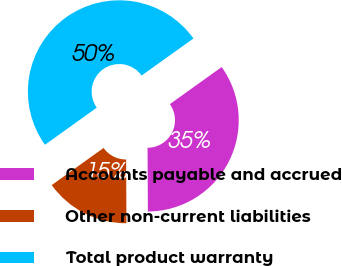<chart> <loc_0><loc_0><loc_500><loc_500><pie_chart><fcel>Accounts payable and accrued<fcel>Other non-current liabilities<fcel>Total product warranty<nl><fcel>34.81%<fcel>15.19%<fcel>50.0%<nl></chart> 